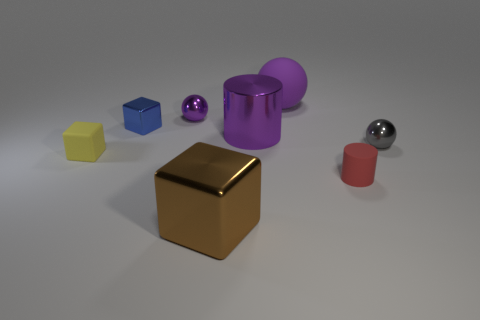Are there any other things that are the same material as the small blue thing?
Your answer should be very brief. Yes. How many large things are metallic cylinders or gray rubber cylinders?
Keep it short and to the point. 1. How many large objects are left of the large purple metallic cylinder and behind the purple cylinder?
Offer a very short reply. 0. Is the number of big purple shiny cylinders greater than the number of things?
Your answer should be very brief. No. How many other objects are there of the same shape as the big purple matte object?
Ensure brevity in your answer.  2. Is the big sphere the same color as the shiny cylinder?
Keep it short and to the point. Yes. There is a object that is to the right of the purple rubber object and on the left side of the gray metallic ball; what material is it made of?
Ensure brevity in your answer.  Rubber. How big is the red thing?
Offer a very short reply. Small. There is a block that is behind the tiny shiny thing in front of the blue shiny object; what number of purple metal things are behind it?
Your answer should be compact. 1. What shape is the small object that is in front of the thing that is on the left side of the blue object?
Provide a short and direct response. Cylinder. 